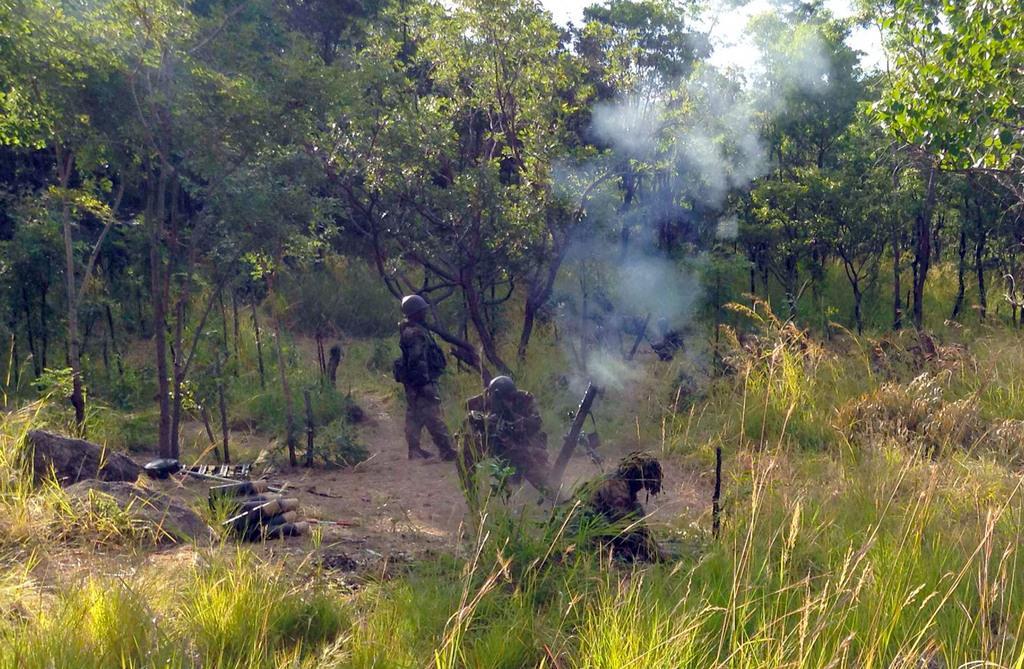In one or two sentences, can you explain what this image depicts? In this picture there are soldiers in the center of the image and there are trees at the top side of the image, there is grassland at the bottom side of the image. 